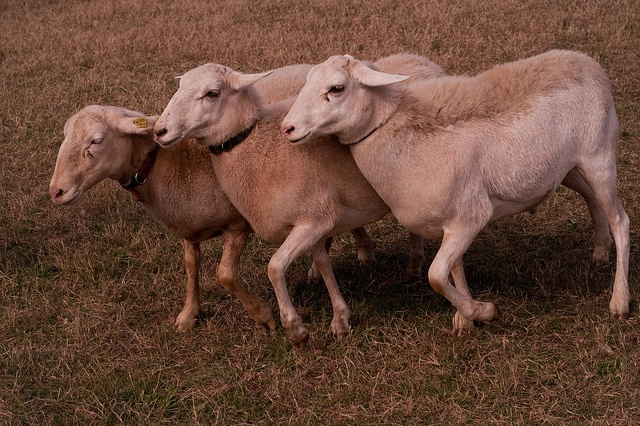Describe the objects in this image and their specific colors. I can see sheep in maroon, gray, salmon, and lightpink tones, sheep in maroon, brown, and lightpink tones, and sheep in maroon, black, and brown tones in this image. 